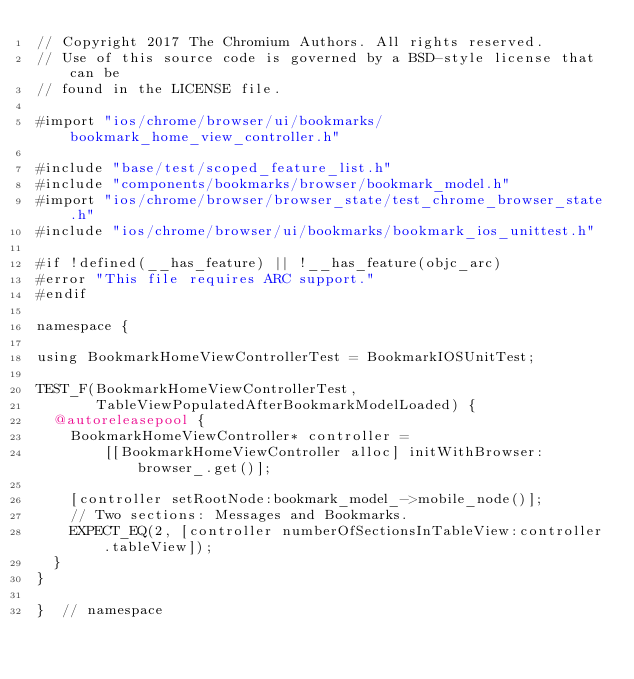Convert code to text. <code><loc_0><loc_0><loc_500><loc_500><_ObjectiveC_>// Copyright 2017 The Chromium Authors. All rights reserved.
// Use of this source code is governed by a BSD-style license that can be
// found in the LICENSE file.

#import "ios/chrome/browser/ui/bookmarks/bookmark_home_view_controller.h"

#include "base/test/scoped_feature_list.h"
#include "components/bookmarks/browser/bookmark_model.h"
#import "ios/chrome/browser/browser_state/test_chrome_browser_state.h"
#include "ios/chrome/browser/ui/bookmarks/bookmark_ios_unittest.h"

#if !defined(__has_feature) || !__has_feature(objc_arc)
#error "This file requires ARC support."
#endif

namespace {

using BookmarkHomeViewControllerTest = BookmarkIOSUnitTest;

TEST_F(BookmarkHomeViewControllerTest,
       TableViewPopulatedAfterBookmarkModelLoaded) {
  @autoreleasepool {
    BookmarkHomeViewController* controller =
        [[BookmarkHomeViewController alloc] initWithBrowser:browser_.get()];

    [controller setRootNode:bookmark_model_->mobile_node()];
    // Two sections: Messages and Bookmarks.
    EXPECT_EQ(2, [controller numberOfSectionsInTableView:controller.tableView]);
  }
}

}  // namespace
</code> 